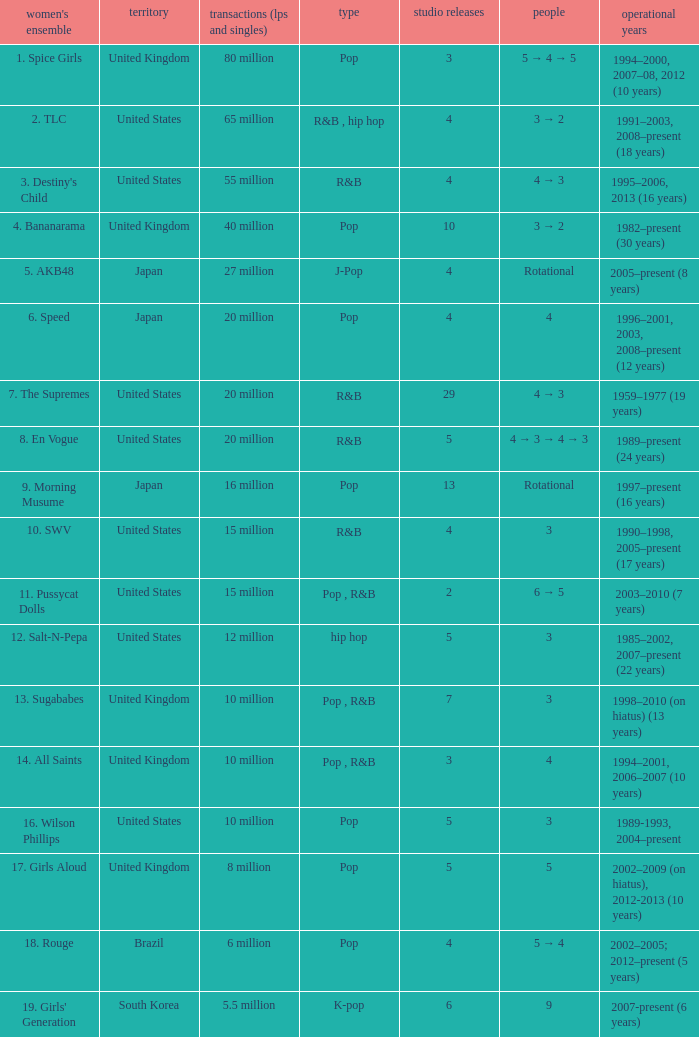How many members were in the group that sold 65 million albums and singles? 3 → 2. 